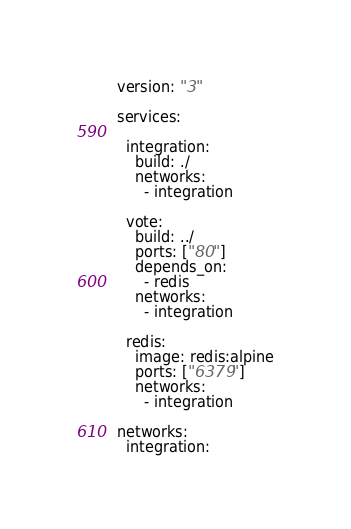Convert code to text. <code><loc_0><loc_0><loc_500><loc_500><_YAML_>version: "3"

services:

  integration:
    build: ./
    networks:
      - integration

  vote:
    build: ../
    ports: ["80"]
    depends_on:
      - redis
    networks:
      - integration

  redis:
    image: redis:alpine
    ports: ["6379"]
    networks:
      - integration

networks:
  integration:</code> 